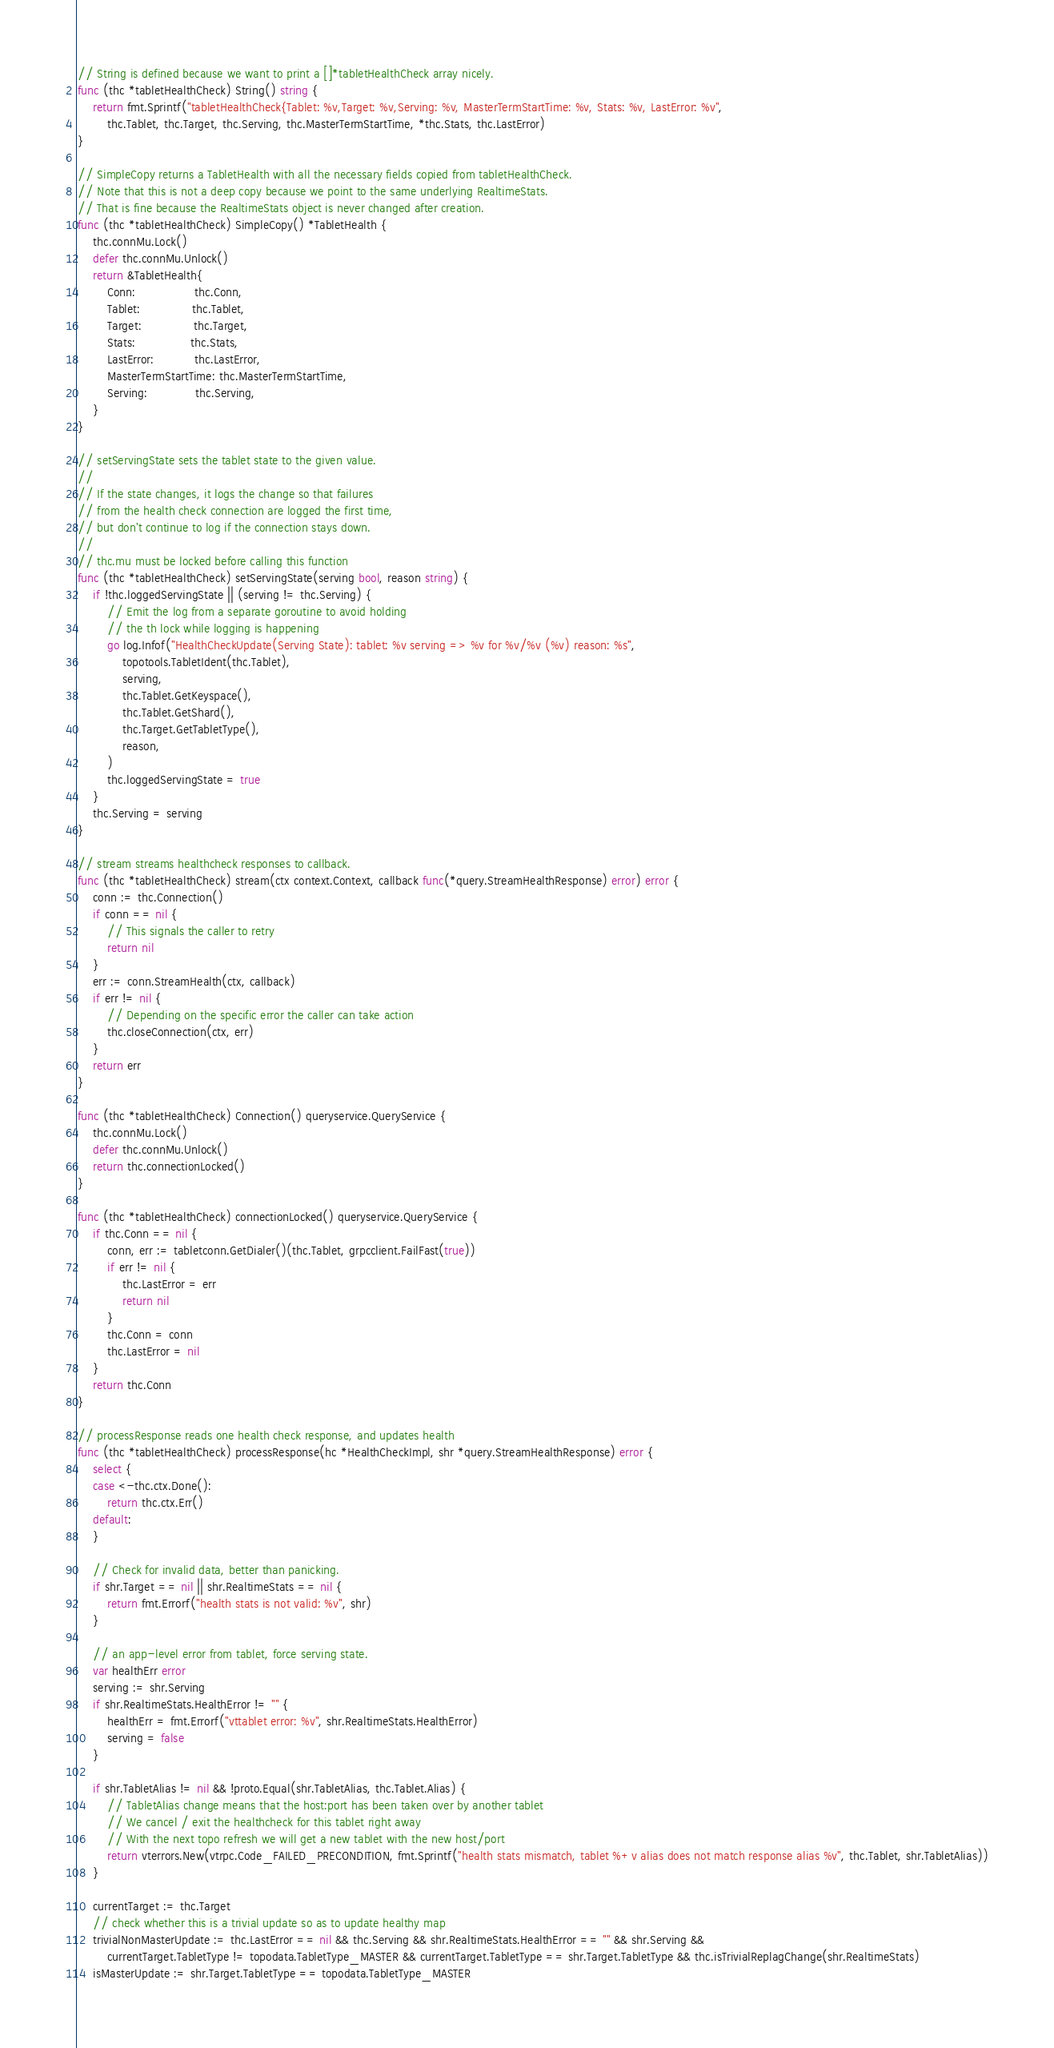Convert code to text. <code><loc_0><loc_0><loc_500><loc_500><_Go_>// String is defined because we want to print a []*tabletHealthCheck array nicely.
func (thc *tabletHealthCheck) String() string {
	return fmt.Sprintf("tabletHealthCheck{Tablet: %v,Target: %v,Serving: %v, MasterTermStartTime: %v, Stats: %v, LastError: %v",
		thc.Tablet, thc.Target, thc.Serving, thc.MasterTermStartTime, *thc.Stats, thc.LastError)
}

// SimpleCopy returns a TabletHealth with all the necessary fields copied from tabletHealthCheck.
// Note that this is not a deep copy because we point to the same underlying RealtimeStats.
// That is fine because the RealtimeStats object is never changed after creation.
func (thc *tabletHealthCheck) SimpleCopy() *TabletHealth {
	thc.connMu.Lock()
	defer thc.connMu.Unlock()
	return &TabletHealth{
		Conn:                thc.Conn,
		Tablet:              thc.Tablet,
		Target:              thc.Target,
		Stats:               thc.Stats,
		LastError:           thc.LastError,
		MasterTermStartTime: thc.MasterTermStartTime,
		Serving:             thc.Serving,
	}
}

// setServingState sets the tablet state to the given value.
//
// If the state changes, it logs the change so that failures
// from the health check connection are logged the first time,
// but don't continue to log if the connection stays down.
//
// thc.mu must be locked before calling this function
func (thc *tabletHealthCheck) setServingState(serving bool, reason string) {
	if !thc.loggedServingState || (serving != thc.Serving) {
		// Emit the log from a separate goroutine to avoid holding
		// the th lock while logging is happening
		go log.Infof("HealthCheckUpdate(Serving State): tablet: %v serving => %v for %v/%v (%v) reason: %s",
			topotools.TabletIdent(thc.Tablet),
			serving,
			thc.Tablet.GetKeyspace(),
			thc.Tablet.GetShard(),
			thc.Target.GetTabletType(),
			reason,
		)
		thc.loggedServingState = true
	}
	thc.Serving = serving
}

// stream streams healthcheck responses to callback.
func (thc *tabletHealthCheck) stream(ctx context.Context, callback func(*query.StreamHealthResponse) error) error {
	conn := thc.Connection()
	if conn == nil {
		// This signals the caller to retry
		return nil
	}
	err := conn.StreamHealth(ctx, callback)
	if err != nil {
		// Depending on the specific error the caller can take action
		thc.closeConnection(ctx, err)
	}
	return err
}

func (thc *tabletHealthCheck) Connection() queryservice.QueryService {
	thc.connMu.Lock()
	defer thc.connMu.Unlock()
	return thc.connectionLocked()
}

func (thc *tabletHealthCheck) connectionLocked() queryservice.QueryService {
	if thc.Conn == nil {
		conn, err := tabletconn.GetDialer()(thc.Tablet, grpcclient.FailFast(true))
		if err != nil {
			thc.LastError = err
			return nil
		}
		thc.Conn = conn
		thc.LastError = nil
	}
	return thc.Conn
}

// processResponse reads one health check response, and updates health
func (thc *tabletHealthCheck) processResponse(hc *HealthCheckImpl, shr *query.StreamHealthResponse) error {
	select {
	case <-thc.ctx.Done():
		return thc.ctx.Err()
	default:
	}

	// Check for invalid data, better than panicking.
	if shr.Target == nil || shr.RealtimeStats == nil {
		return fmt.Errorf("health stats is not valid: %v", shr)
	}

	// an app-level error from tablet, force serving state.
	var healthErr error
	serving := shr.Serving
	if shr.RealtimeStats.HealthError != "" {
		healthErr = fmt.Errorf("vttablet error: %v", shr.RealtimeStats.HealthError)
		serving = false
	}

	if shr.TabletAlias != nil && !proto.Equal(shr.TabletAlias, thc.Tablet.Alias) {
		// TabletAlias change means that the host:port has been taken over by another tablet
		// We cancel / exit the healthcheck for this tablet right away
		// With the next topo refresh we will get a new tablet with the new host/port
		return vterrors.New(vtrpc.Code_FAILED_PRECONDITION, fmt.Sprintf("health stats mismatch, tablet %+v alias does not match response alias %v", thc.Tablet, shr.TabletAlias))
	}

	currentTarget := thc.Target
	// check whether this is a trivial update so as to update healthy map
	trivialNonMasterUpdate := thc.LastError == nil && thc.Serving && shr.RealtimeStats.HealthError == "" && shr.Serving &&
		currentTarget.TabletType != topodata.TabletType_MASTER && currentTarget.TabletType == shr.Target.TabletType && thc.isTrivialReplagChange(shr.RealtimeStats)
	isMasterUpdate := shr.Target.TabletType == topodata.TabletType_MASTER</code> 